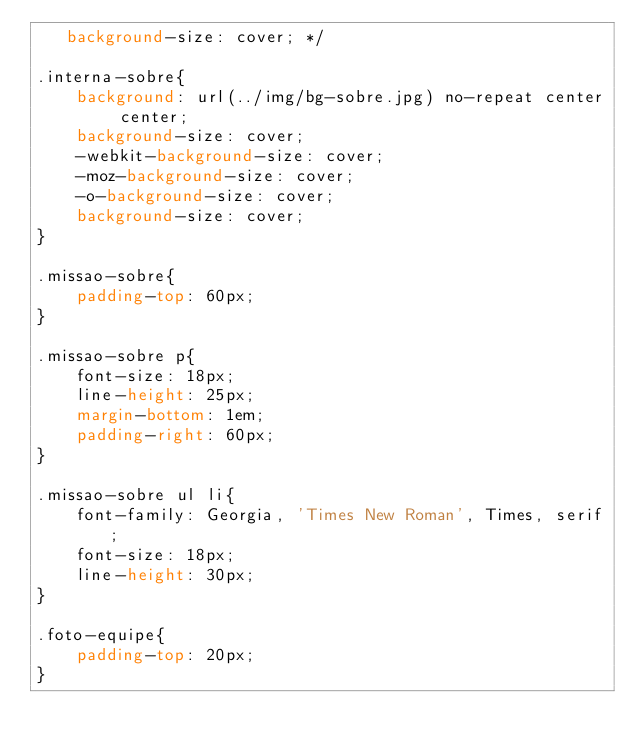<code> <loc_0><loc_0><loc_500><loc_500><_CSS_>   background-size: cover; */

.interna-sobre{
	background: url(../img/bg-sobre.jpg) no-repeat center center;
	background-size: cover;
	-webkit-background-size: cover;
	-moz-background-size: cover;
	-o-background-size: cover;
	background-size: cover;
}

.missao-sobre{
	padding-top: 60px;
}

.missao-sobre p{
	font-size: 18px;
	line-height: 25px;
	margin-bottom: 1em;
	padding-right: 60px;
}

.missao-sobre ul li{
	font-family: Georgia, 'Times New Roman', Times, serif;
	font-size: 18px;
	line-height: 30px;
}

.foto-equipe{
	padding-top: 20px;		
}</code> 